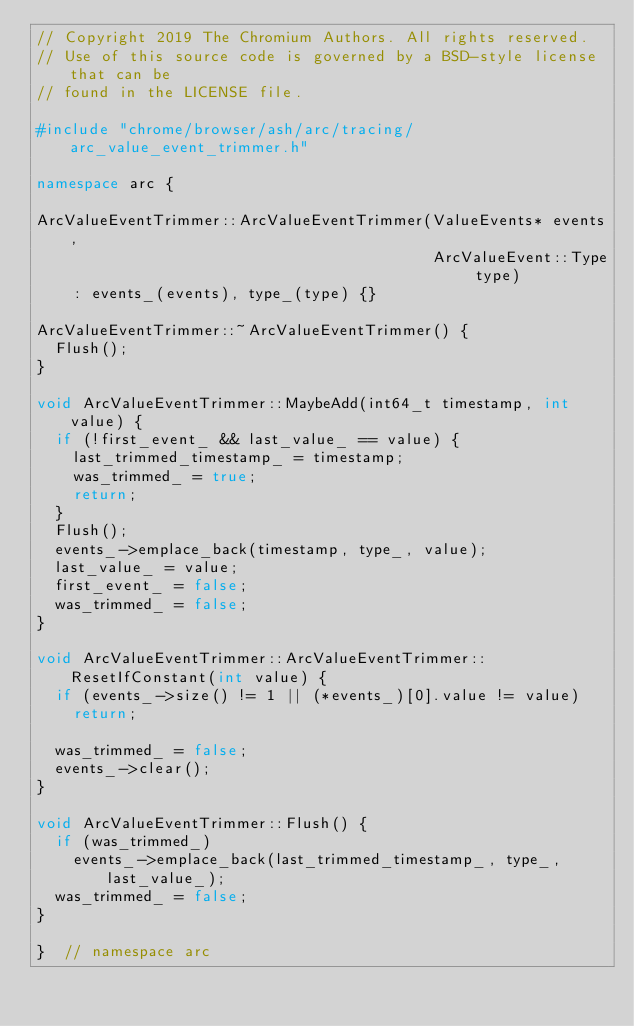<code> <loc_0><loc_0><loc_500><loc_500><_C++_>// Copyright 2019 The Chromium Authors. All rights reserved.
// Use of this source code is governed by a BSD-style license that can be
// found in the LICENSE file.

#include "chrome/browser/ash/arc/tracing/arc_value_event_trimmer.h"

namespace arc {

ArcValueEventTrimmer::ArcValueEventTrimmer(ValueEvents* events,
                                           ArcValueEvent::Type type)
    : events_(events), type_(type) {}

ArcValueEventTrimmer::~ArcValueEventTrimmer() {
  Flush();
}

void ArcValueEventTrimmer::MaybeAdd(int64_t timestamp, int value) {
  if (!first_event_ && last_value_ == value) {
    last_trimmed_timestamp_ = timestamp;
    was_trimmed_ = true;
    return;
  }
  Flush();
  events_->emplace_back(timestamp, type_, value);
  last_value_ = value;
  first_event_ = false;
  was_trimmed_ = false;
}

void ArcValueEventTrimmer::ArcValueEventTrimmer::ResetIfConstant(int value) {
  if (events_->size() != 1 || (*events_)[0].value != value)
    return;

  was_trimmed_ = false;
  events_->clear();
}

void ArcValueEventTrimmer::Flush() {
  if (was_trimmed_)
    events_->emplace_back(last_trimmed_timestamp_, type_, last_value_);
  was_trimmed_ = false;
}

}  // namespace arc
</code> 